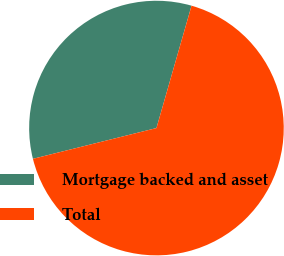Convert chart to OTSL. <chart><loc_0><loc_0><loc_500><loc_500><pie_chart><fcel>Mortgage backed and asset<fcel>Total<nl><fcel>33.33%<fcel>66.67%<nl></chart> 